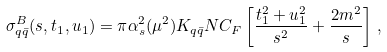Convert formula to latex. <formula><loc_0><loc_0><loc_500><loc_500>\sigma _ { q \bar { q } } ^ { B } ( s , t _ { 1 } , u _ { 1 } ) = \pi \alpha _ { s } ^ { 2 } ( \mu ^ { 2 } ) K _ { q \bar { q } } N C _ { F } \left [ \frac { t _ { 1 } ^ { 2 } + u _ { 1 } ^ { 2 } } { s ^ { 2 } } + \frac { 2 m ^ { 2 } } { s } \right ] \, ,</formula> 